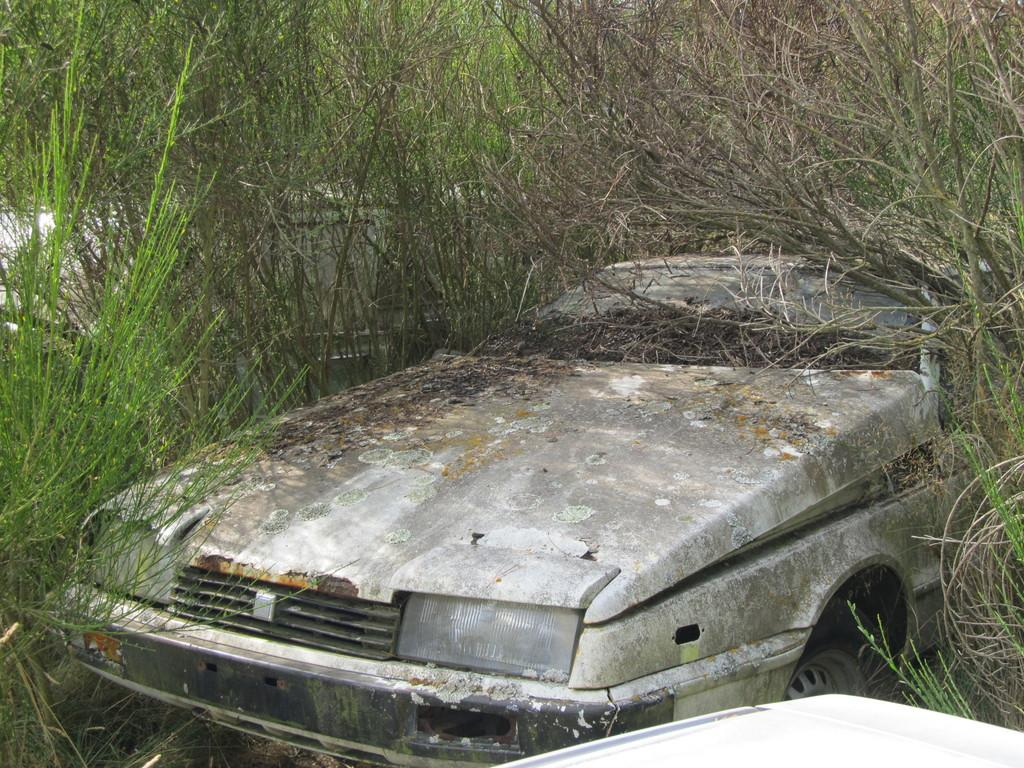What is the main subject in the center of the image? There is an old car in the center of the image. What type of environment surrounds the car in the image? There is grass around the area of the image. What type of frame is around the car in the image? There is no frame around the car in the image; it is surrounded by grass. 